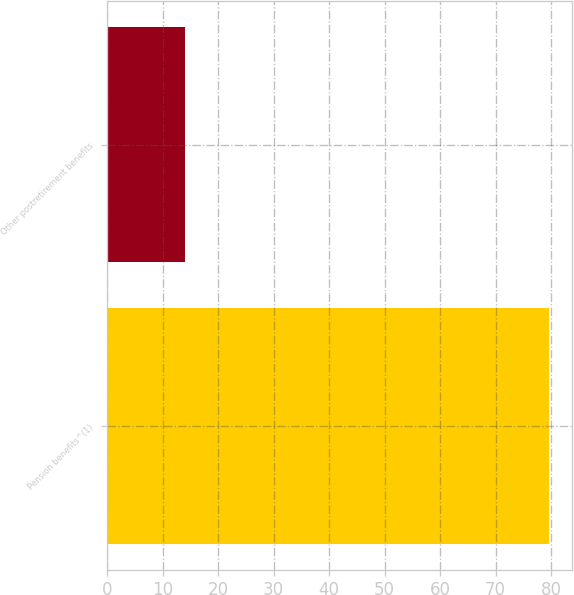<chart> <loc_0><loc_0><loc_500><loc_500><bar_chart><fcel>Pension benefits^(1)<fcel>Other postretirement benefits<nl><fcel>79.7<fcel>14<nl></chart> 